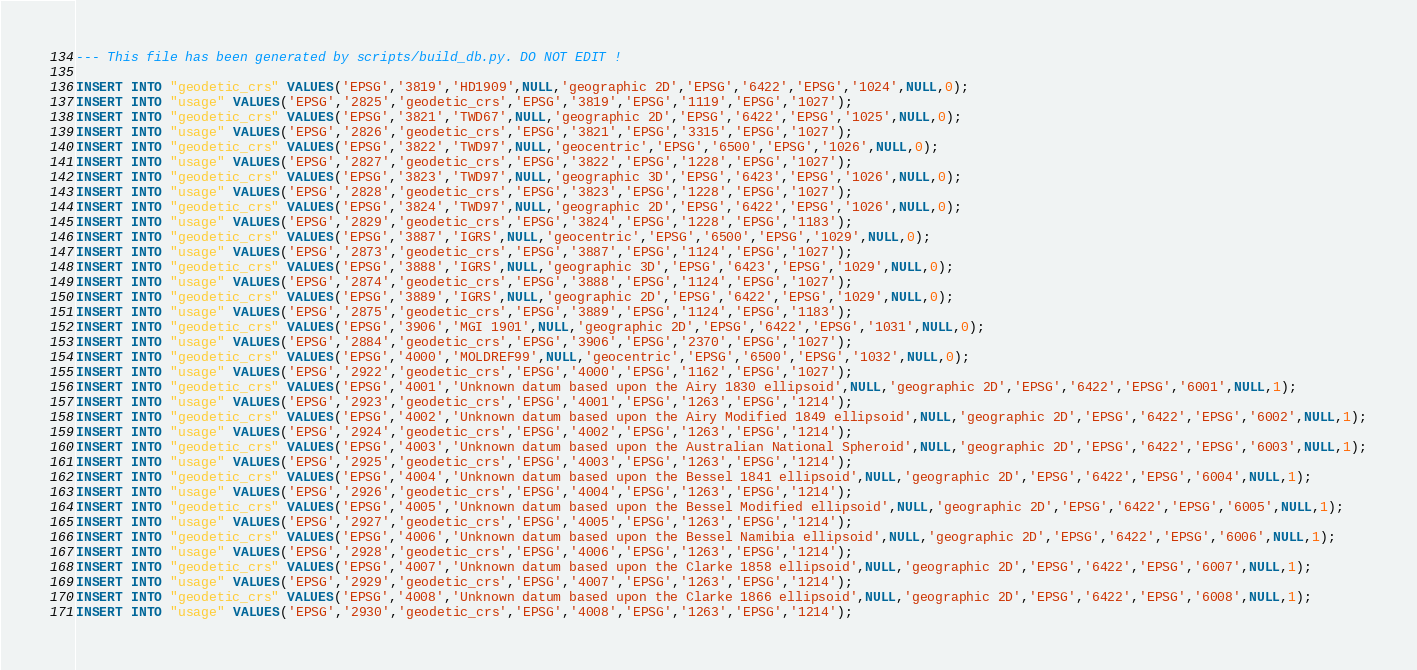Convert code to text. <code><loc_0><loc_0><loc_500><loc_500><_SQL_>--- This file has been generated by scripts/build_db.py. DO NOT EDIT !

INSERT INTO "geodetic_crs" VALUES('EPSG','3819','HD1909',NULL,'geographic 2D','EPSG','6422','EPSG','1024',NULL,0);
INSERT INTO "usage" VALUES('EPSG','2825','geodetic_crs','EPSG','3819','EPSG','1119','EPSG','1027');
INSERT INTO "geodetic_crs" VALUES('EPSG','3821','TWD67',NULL,'geographic 2D','EPSG','6422','EPSG','1025',NULL,0);
INSERT INTO "usage" VALUES('EPSG','2826','geodetic_crs','EPSG','3821','EPSG','3315','EPSG','1027');
INSERT INTO "geodetic_crs" VALUES('EPSG','3822','TWD97',NULL,'geocentric','EPSG','6500','EPSG','1026',NULL,0);
INSERT INTO "usage" VALUES('EPSG','2827','geodetic_crs','EPSG','3822','EPSG','1228','EPSG','1027');
INSERT INTO "geodetic_crs" VALUES('EPSG','3823','TWD97',NULL,'geographic 3D','EPSG','6423','EPSG','1026',NULL,0);
INSERT INTO "usage" VALUES('EPSG','2828','geodetic_crs','EPSG','3823','EPSG','1228','EPSG','1027');
INSERT INTO "geodetic_crs" VALUES('EPSG','3824','TWD97',NULL,'geographic 2D','EPSG','6422','EPSG','1026',NULL,0);
INSERT INTO "usage" VALUES('EPSG','2829','geodetic_crs','EPSG','3824','EPSG','1228','EPSG','1183');
INSERT INTO "geodetic_crs" VALUES('EPSG','3887','IGRS',NULL,'geocentric','EPSG','6500','EPSG','1029',NULL,0);
INSERT INTO "usage" VALUES('EPSG','2873','geodetic_crs','EPSG','3887','EPSG','1124','EPSG','1027');
INSERT INTO "geodetic_crs" VALUES('EPSG','3888','IGRS',NULL,'geographic 3D','EPSG','6423','EPSG','1029',NULL,0);
INSERT INTO "usage" VALUES('EPSG','2874','geodetic_crs','EPSG','3888','EPSG','1124','EPSG','1027');
INSERT INTO "geodetic_crs" VALUES('EPSG','3889','IGRS',NULL,'geographic 2D','EPSG','6422','EPSG','1029',NULL,0);
INSERT INTO "usage" VALUES('EPSG','2875','geodetic_crs','EPSG','3889','EPSG','1124','EPSG','1183');
INSERT INTO "geodetic_crs" VALUES('EPSG','3906','MGI 1901',NULL,'geographic 2D','EPSG','6422','EPSG','1031',NULL,0);
INSERT INTO "usage" VALUES('EPSG','2884','geodetic_crs','EPSG','3906','EPSG','2370','EPSG','1027');
INSERT INTO "geodetic_crs" VALUES('EPSG','4000','MOLDREF99',NULL,'geocentric','EPSG','6500','EPSG','1032',NULL,0);
INSERT INTO "usage" VALUES('EPSG','2922','geodetic_crs','EPSG','4000','EPSG','1162','EPSG','1027');
INSERT INTO "geodetic_crs" VALUES('EPSG','4001','Unknown datum based upon the Airy 1830 ellipsoid',NULL,'geographic 2D','EPSG','6422','EPSG','6001',NULL,1);
INSERT INTO "usage" VALUES('EPSG','2923','geodetic_crs','EPSG','4001','EPSG','1263','EPSG','1214');
INSERT INTO "geodetic_crs" VALUES('EPSG','4002','Unknown datum based upon the Airy Modified 1849 ellipsoid',NULL,'geographic 2D','EPSG','6422','EPSG','6002',NULL,1);
INSERT INTO "usage" VALUES('EPSG','2924','geodetic_crs','EPSG','4002','EPSG','1263','EPSG','1214');
INSERT INTO "geodetic_crs" VALUES('EPSG','4003','Unknown datum based upon the Australian National Spheroid',NULL,'geographic 2D','EPSG','6422','EPSG','6003',NULL,1);
INSERT INTO "usage" VALUES('EPSG','2925','geodetic_crs','EPSG','4003','EPSG','1263','EPSG','1214');
INSERT INTO "geodetic_crs" VALUES('EPSG','4004','Unknown datum based upon the Bessel 1841 ellipsoid',NULL,'geographic 2D','EPSG','6422','EPSG','6004',NULL,1);
INSERT INTO "usage" VALUES('EPSG','2926','geodetic_crs','EPSG','4004','EPSG','1263','EPSG','1214');
INSERT INTO "geodetic_crs" VALUES('EPSG','4005','Unknown datum based upon the Bessel Modified ellipsoid',NULL,'geographic 2D','EPSG','6422','EPSG','6005',NULL,1);
INSERT INTO "usage" VALUES('EPSG','2927','geodetic_crs','EPSG','4005','EPSG','1263','EPSG','1214');
INSERT INTO "geodetic_crs" VALUES('EPSG','4006','Unknown datum based upon the Bessel Namibia ellipsoid',NULL,'geographic 2D','EPSG','6422','EPSG','6006',NULL,1);
INSERT INTO "usage" VALUES('EPSG','2928','geodetic_crs','EPSG','4006','EPSG','1263','EPSG','1214');
INSERT INTO "geodetic_crs" VALUES('EPSG','4007','Unknown datum based upon the Clarke 1858 ellipsoid',NULL,'geographic 2D','EPSG','6422','EPSG','6007',NULL,1);
INSERT INTO "usage" VALUES('EPSG','2929','geodetic_crs','EPSG','4007','EPSG','1263','EPSG','1214');
INSERT INTO "geodetic_crs" VALUES('EPSG','4008','Unknown datum based upon the Clarke 1866 ellipsoid',NULL,'geographic 2D','EPSG','6422','EPSG','6008',NULL,1);
INSERT INTO "usage" VALUES('EPSG','2930','geodetic_crs','EPSG','4008','EPSG','1263','EPSG','1214');</code> 